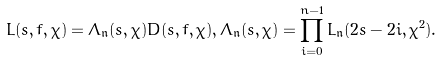<formula> <loc_0><loc_0><loc_500><loc_500>L ( s , f , \chi ) = \Lambda _ { \mathfrak { n } } ( s , \chi ) D ( s , f , \chi ) , \Lambda _ { \mathfrak { n } } ( s , \chi ) = \prod _ { i = 0 } ^ { n - 1 } L _ { \mathfrak { n } } ( 2 s - 2 i , \chi ^ { 2 } ) .</formula> 